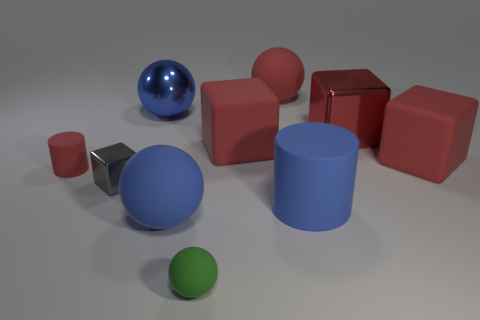Subtract all spheres. How many objects are left? 6 Subtract 2 blocks. How many blocks are left? 2 Subtract all purple blocks. Subtract all yellow cylinders. How many blocks are left? 4 Subtract all green cylinders. How many gray cubes are left? 1 Subtract all red rubber balls. Subtract all tiny red cylinders. How many objects are left? 8 Add 2 small shiny cubes. How many small shiny cubes are left? 3 Add 8 tiny blue metal blocks. How many tiny blue metal blocks exist? 8 Subtract all green spheres. How many spheres are left? 3 Subtract all large red cubes. How many cubes are left? 1 Subtract 0 cyan spheres. How many objects are left? 10 